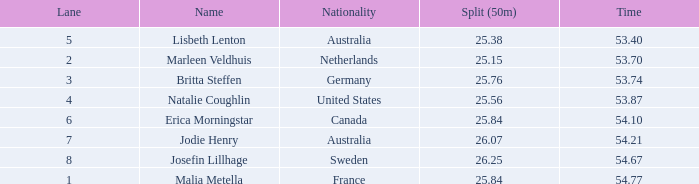What is the total of lane(s) for swimmers from Sweden with a 50m split of faster than 26.25? None. 